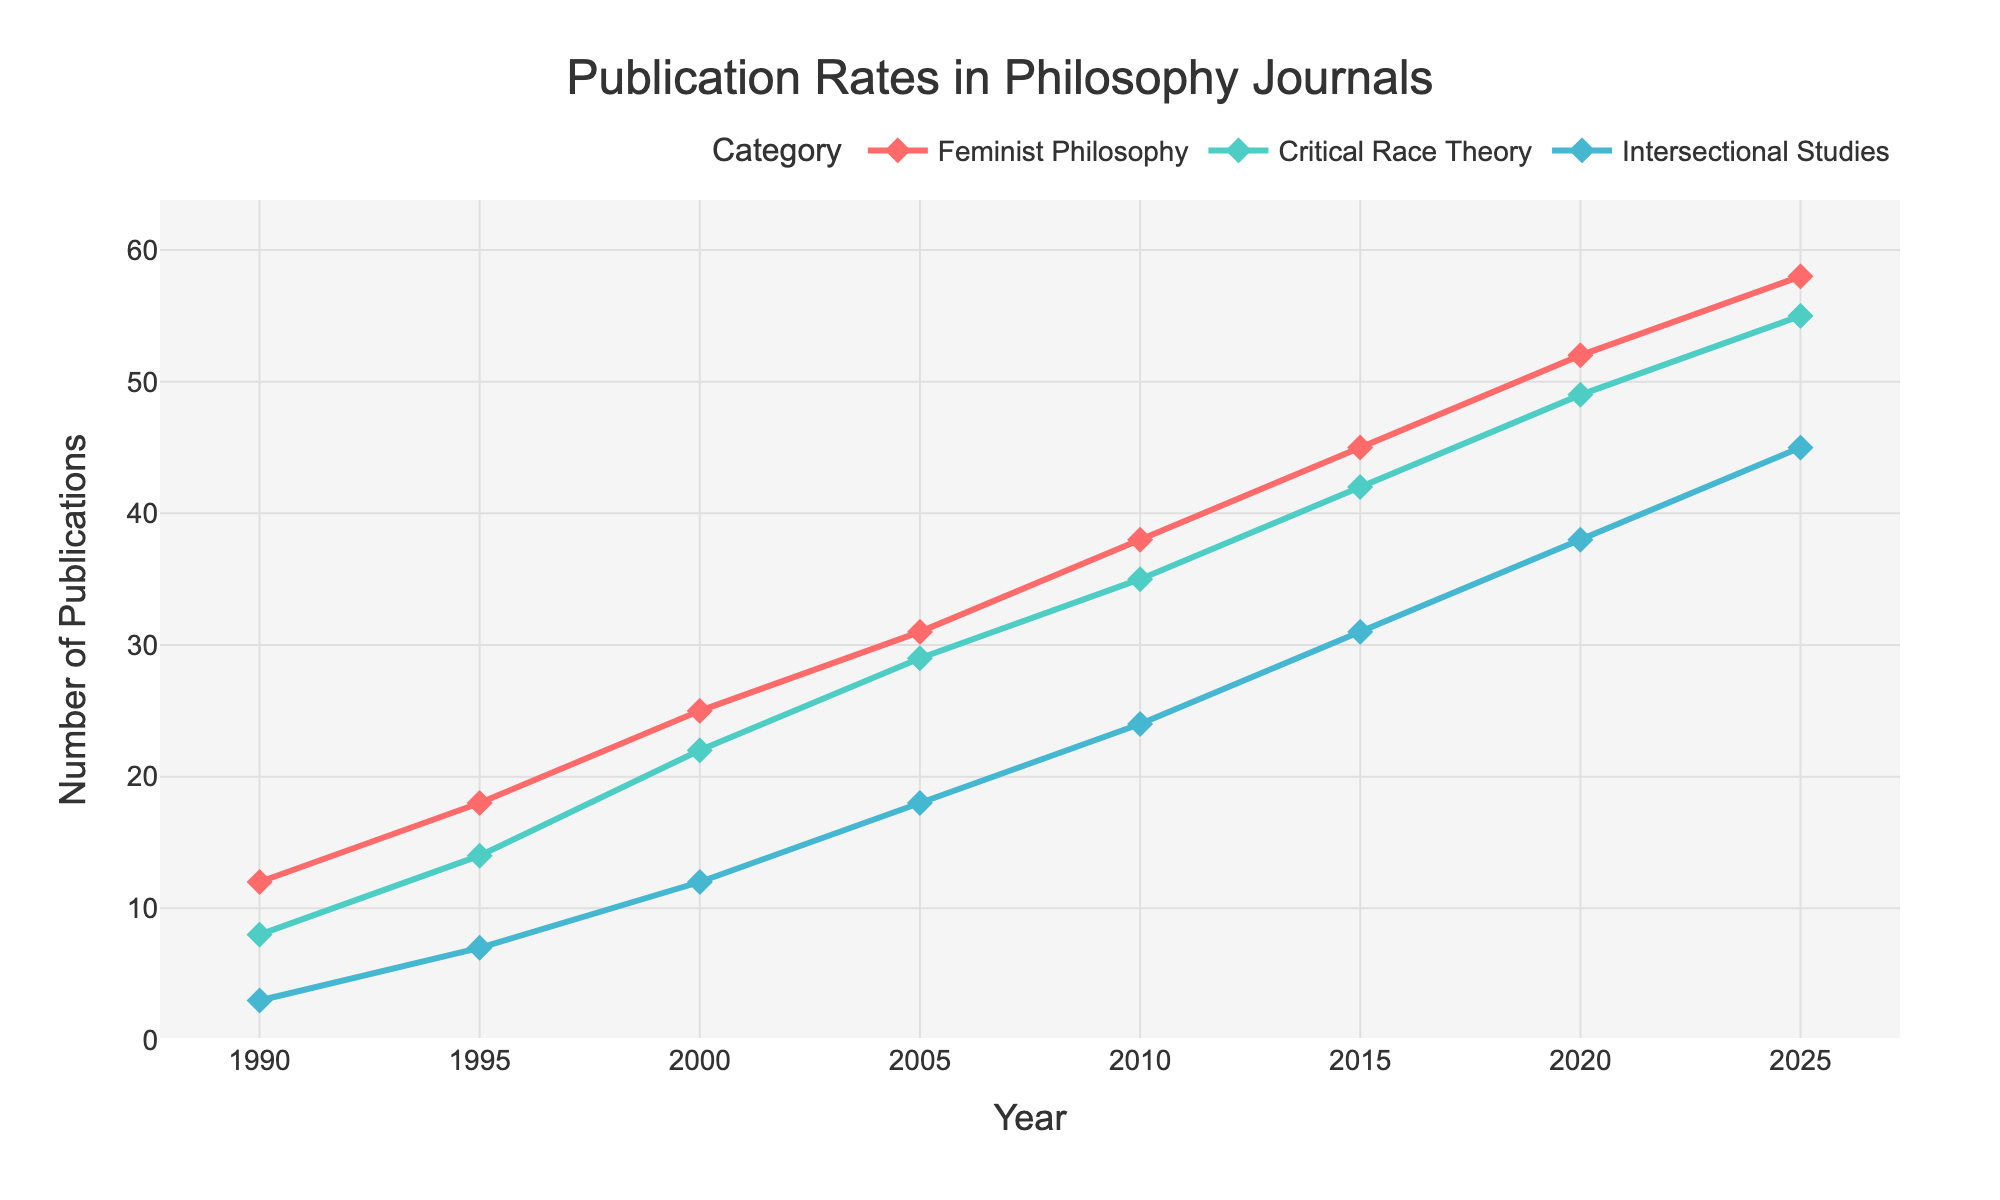What year did the publication rate of Critical Race Theory first surpass 20 articles? To determine the year when Critical Race Theory publications first surpass 20 articles, locate the Critical Race Theory line and find the year when it crosses the 20-article mark. According to the chart, this happens in the year 2000.
Answer: 2000 How many more publications in Feminist Philosophy were there in 2020 compared to in 1990? Identify the number of Feminist Philosophy publications in 2020 and 1990 from the chart, then subtract the 1990 figure from the 2020 figure. For 2020, there were 52 publications, and for 1990, there were 12. Therefore, the difference is 52 - 12 = 40.
Answer: 40 Between which two consecutive years was the largest increase in Intersectional Studies publications observed? Observe the Intersectional Studies line and identify the steepest upward slope between two consecutive years. The largest increase is between 2020 and 2025 where the publications go from 38 to 45, an increase of 7.
Answer: 2020 and 2025 By how many articles did the publication rate of Critical Race Theory exceed that of Intersectional Studies in 2025? Identify the number of publications for both Critical Race Theory and Intersectional Studies in 2025 and subtract the latter from the former. There were 55 publications for Critical Race Theory and 45 for Intersectional Studies, resulting in a difference of 55 - 45 = 10.
Answer: 10 In which year did all three categories (Feminist Philosophy, Critical Race Theory, and Intersectional Studies) have an equal publication rate? Locate a point where all three lines intersect. According to the chart, there is no single point where all three categories have an equal number of publications at the same time.
Answer: No year How did the publication rates of Feminist Philosophy and Critical Race Theory compare in 2010? Identify the publication numbers for both categories in 2010 from the chart. Feminist Philosophy had 38 publications, while Critical Race Theory had 35. Therefore, Feminist Philosophy surpassed Critical Race Theory by 3 publications.
Answer: Feminist Philosophy had 3 more publications What is the average number of Intersectional Studies publications in the first three years shown (1990, 1995, 2000)? Sum the number of publications for Intersectional Studies in 1990, 1995, and 2000, then divide by 3. The values are 3, 7, and 12. Therefore, (3 + 7 + 12) / 3 = 22 / 3 ≈ 7.33.
Answer: 7.33 Which category showed the highest overall growth from 1990 to 2025? Examine the starting and ending publication rates for each category from 1990 to 2025 and calculate the difference. Feminist Philosophy grew from 12 to 58 (46 publications), Critical Race Theory from 8 to 55 (47 publications), and Intersectional Studies from 3 to 45 (42 publications). Critical Race Theory shows the highest growth.
Answer: Critical Race Theory How many total publications were there across all three categories in 2005? Add the number of publications for Feminist Philosophy, Critical Race Theory, and Intersectional Studies in 2005. The numbers are 31, 29, and 18 respectively. Therefore, 31 + 29 + 18 = 78.
Answer: 78 